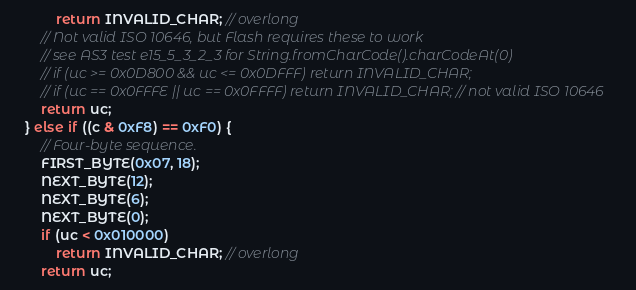<code> <loc_0><loc_0><loc_500><loc_500><_C++_>            return INVALID_CHAR; // overlong
        // Not valid ISO 10646, but Flash requires these to work
        // see AS3 test e15_5_3_2_3 for String.fromCharCode().charCodeAt(0)
        // if (uc >= 0x0D800 && uc <= 0x0DFFF) return INVALID_CHAR;
        // if (uc == 0x0FFFE || uc == 0x0FFFF) return INVALID_CHAR; // not valid ISO 10646
        return uc;
    } else if ((c & 0xF8) == 0xF0) {
        // Four-byte sequence.
        FIRST_BYTE(0x07, 18);
        NEXT_BYTE(12);
        NEXT_BYTE(6);
        NEXT_BYTE(0);
        if (uc < 0x010000)
            return INVALID_CHAR; // overlong
        return uc;</code> 